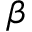Convert formula to latex. <formula><loc_0><loc_0><loc_500><loc_500>_ { \beta }</formula> 